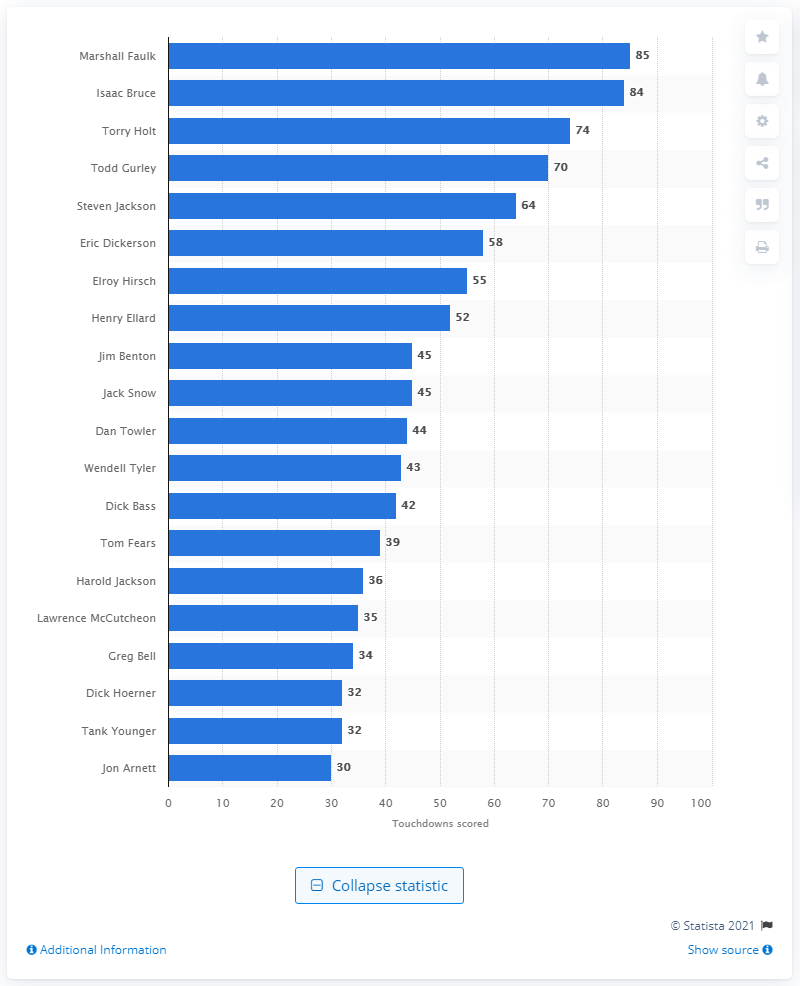Give some essential details in this illustration. Marshall Faulk has scored a total of 85 touchdowns. I am Marshall Faulk, the career touchdown leader of the Los Angeles (Cleveland/St. Louis) Rams. 